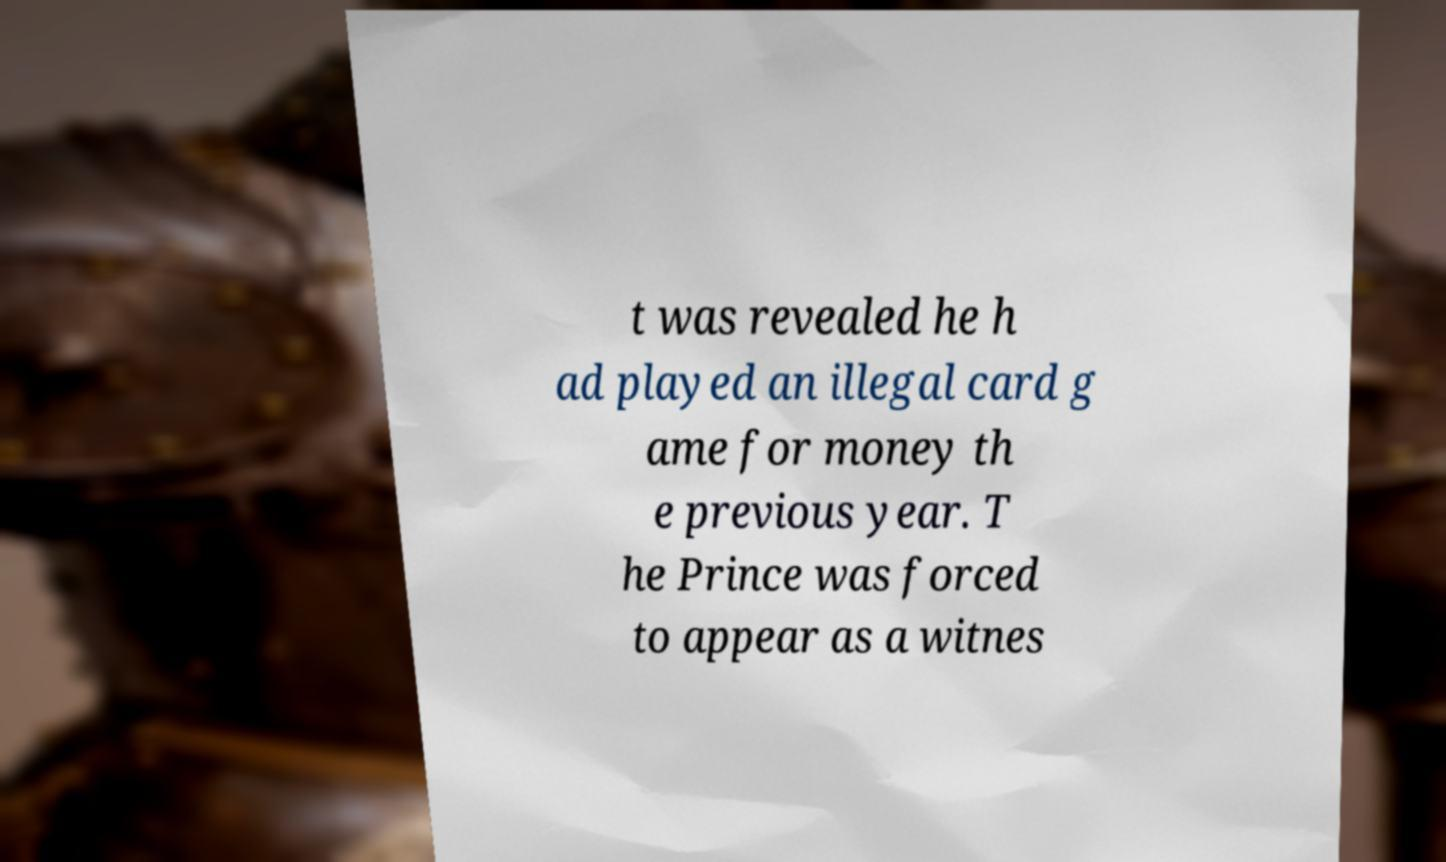Can you accurately transcribe the text from the provided image for me? t was revealed he h ad played an illegal card g ame for money th e previous year. T he Prince was forced to appear as a witnes 